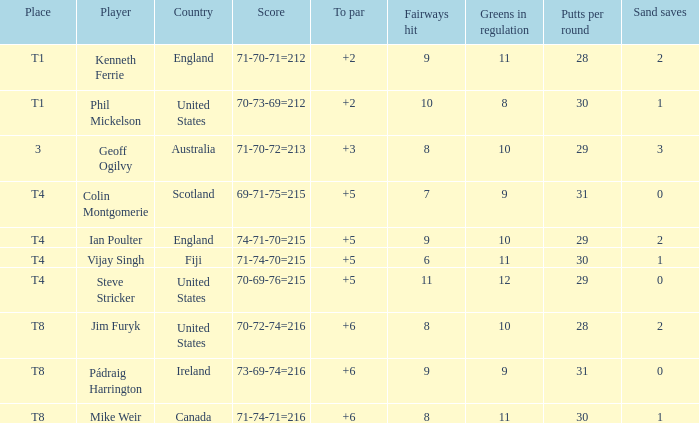What score to par did Mike Weir have? 6.0. 